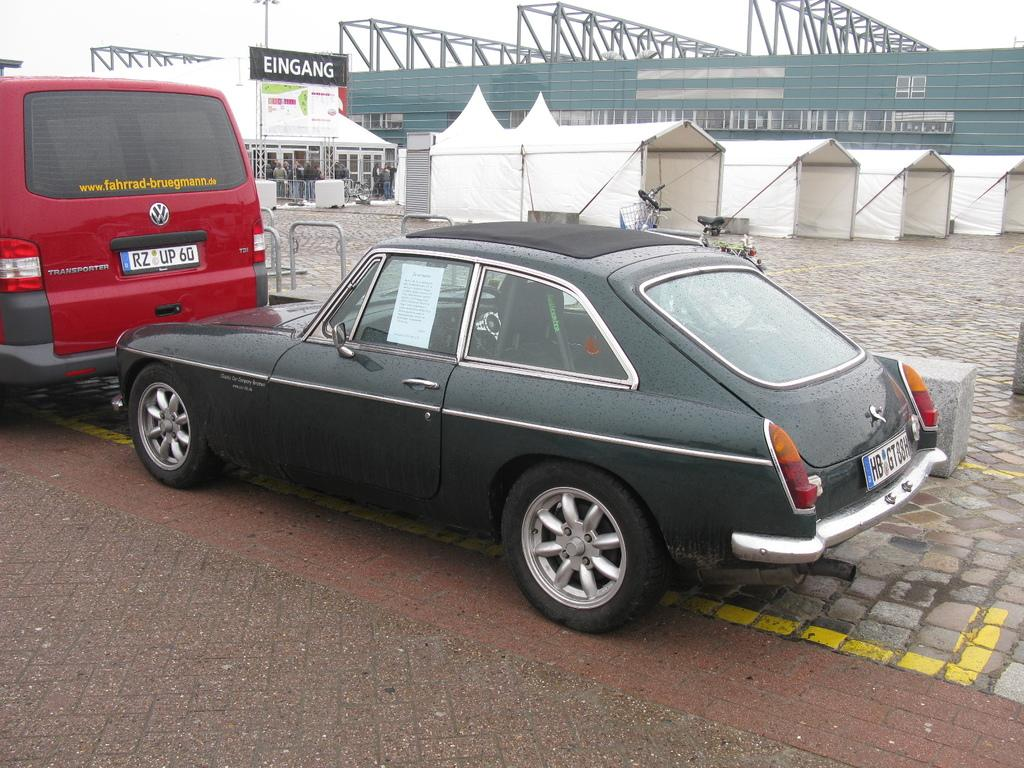Where was the image taken? The image was clicked outside. What can be seen in the image besides the outdoor setting? There are vehicles, a pavement, tents, metal rods, a group of persons, text on a banner, a building, and other objects visible in the image. Can you describe the vehicles in the image? The provided facts do not specify the type or number of vehicles in the image. What is the purpose of the tents in the image? The purpose of the tents in the image cannot be determined from the provided facts. What does the text on the banner say? The provided facts do not specify the text on the banner. How much advice can be seen in the image? There is no advice visible in the image. Is there a bath in the image? There is no bath present in the image. 